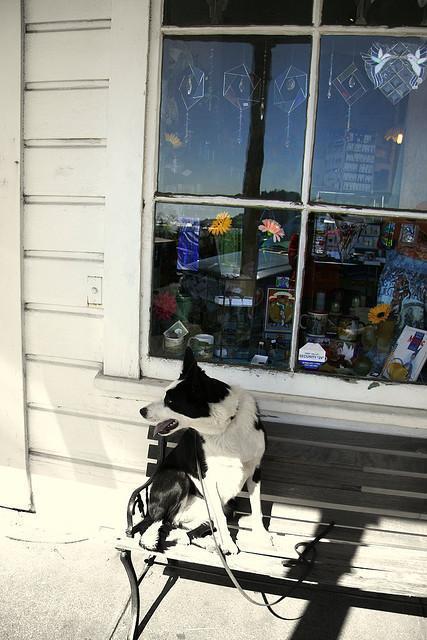How many benches are there?
Give a very brief answer. 1. How many zebra are standing in the grass?
Give a very brief answer. 0. 